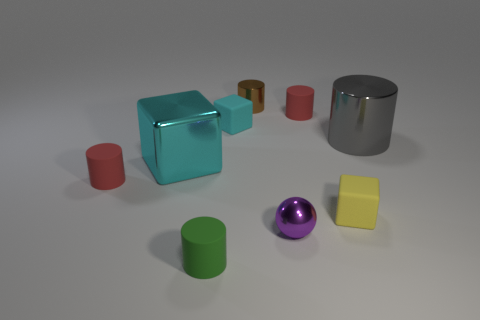Subtract all matte blocks. How many blocks are left? 1 Add 1 metal things. How many objects exist? 10 Subtract all green cylinders. How many cylinders are left? 4 Subtract all cylinders. How many objects are left? 4 Subtract all purple balls. How many cyan blocks are left? 2 Add 6 yellow cylinders. How many yellow cylinders exist? 6 Subtract 0 blue blocks. How many objects are left? 9 Subtract 1 blocks. How many blocks are left? 2 Subtract all yellow blocks. Subtract all purple balls. How many blocks are left? 2 Subtract all small yellow matte blocks. Subtract all big gray shiny cylinders. How many objects are left? 7 